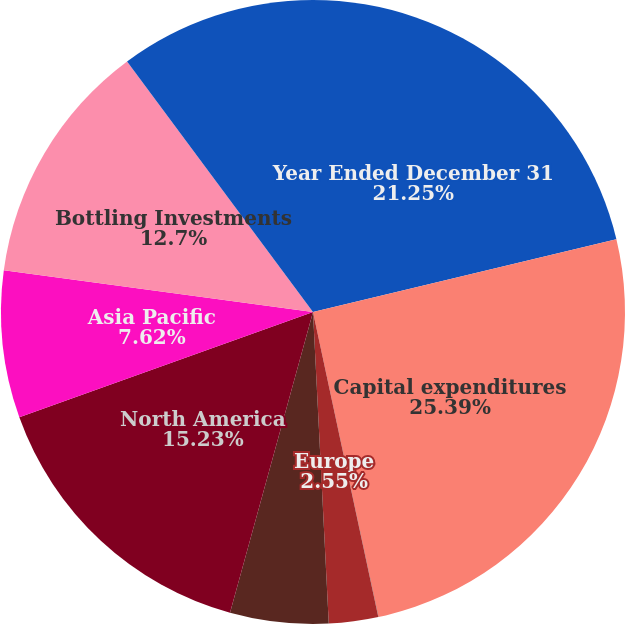Convert chart. <chart><loc_0><loc_0><loc_500><loc_500><pie_chart><fcel>Year Ended December 31<fcel>Capital expenditures<fcel>Eurasia & Africa<fcel>Europe<fcel>Latin America<fcel>North America<fcel>Asia Pacific<fcel>Bottling Investments<fcel>Corporate<nl><fcel>21.25%<fcel>25.38%<fcel>0.01%<fcel>2.55%<fcel>5.09%<fcel>15.23%<fcel>7.62%<fcel>12.7%<fcel>10.16%<nl></chart> 